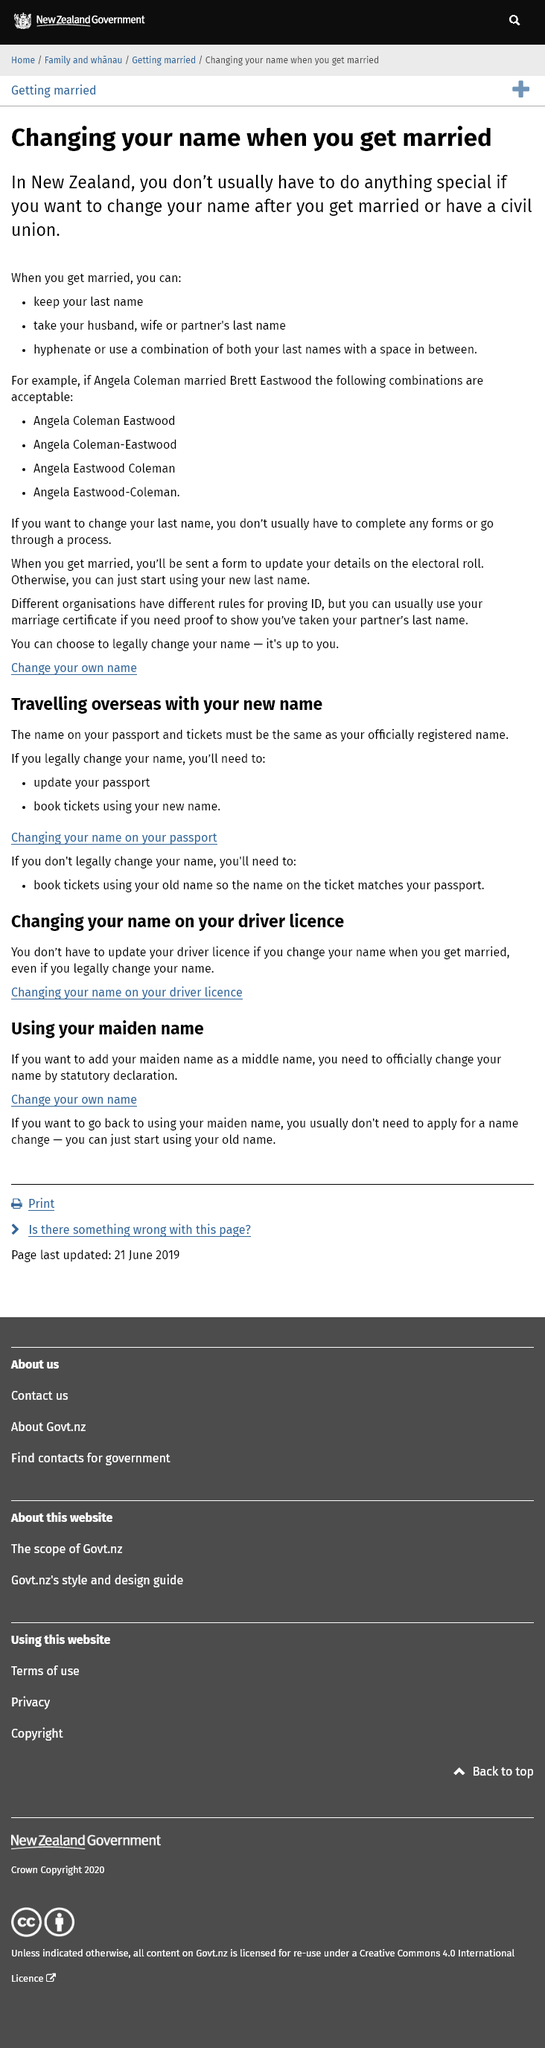Indicate a few pertinent items in this graphic. The name listed on your passport and tickets must be identical to the name that is officially registered. To change your name on the electoral roll after getting married, you must fill out a form to update your details on the electoral roll if you wish to change your last name. In New Zealand, when getting married, individuals have the option to retain their last name, adopt their spouse's last name, combine both last names through hyphenation, or create a new last name by combining parts of both last names. If you legally change your name, you must update your passport and book tickets using your new name. If it is your desire to revert to using your maiden name, you are not required to file a name change application in order to do so. You may simply begin using your previous surname. 